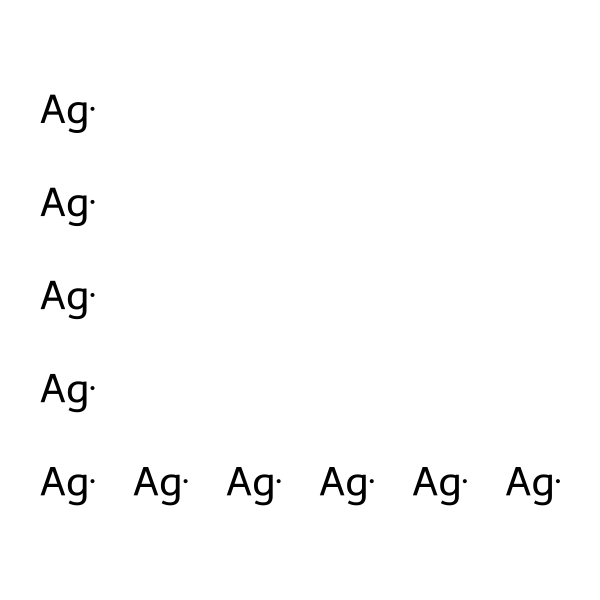What is the chemical element represented in this structure? The structure contains only silver atoms as indicated by the presence of the symbol 'Ag' repeated multiple times.
Answer: silver How many silver atoms are present in the nanosilver particle? The SMILES representation shows 'Ag' repeated ten times, indicating there are ten individual silver atoms in this structure.
Answer: ten What type of material does this chemical structure represent? The presence of nanoscale silver particles indicates that the material is classified as a nanomaterial, specifically a metallic nanomaterial due to its metallic nature.
Answer: nanomaterial Is this structure likely to exhibit antimicrobial properties? Silver is well-known for its antimicrobial properties; thus, the nanosilver structure is highly likely to exhibit these properties due to the unique characteristics of nanoparticles that enhance reactivity and effectiveness.
Answer: yes What is the significance of particle size in this nanosilver structure? The nanoscale size of these silver particles contributes to an increased surface area to volume ratio, enhancing their reactivity and potential antimicrobial effectiveness compared to larger particles.
Answer: increased reactivity How might the arrangement of silver atoms affect its properties? The arrangement of silver atoms can influence the electronic properties and reactivity; in this case, with multiple isolated silver atoms, the structure suggests potential for enhanced antimicrobial activity due to quantum effects at the nanoscale.
Answer: enhanced antimicrobial activity 